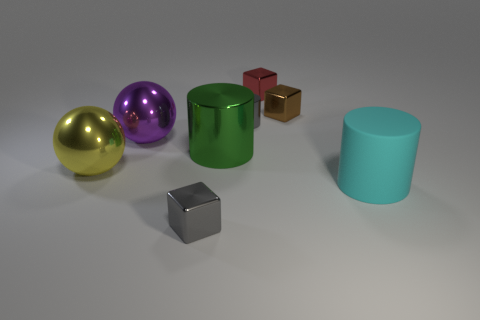There is a big thing that is to the left of the large purple metallic sphere to the left of the big green metal object; what is its material?
Provide a short and direct response. Metal. The cylinder that is the same size as the gray metal cube is what color?
Offer a terse response. Gray. There is a brown metallic thing; is its shape the same as the object that is behind the brown object?
Your answer should be compact. Yes. The thing that is the same color as the tiny cylinder is what shape?
Keep it short and to the point. Cube. There is a gray thing that is left of the cylinder that is behind the purple shiny thing; what number of big green cylinders are in front of it?
Provide a succinct answer. 0. How big is the gray metal object on the right side of the tiny cube in front of the large purple shiny thing?
Offer a very short reply. Small. The yellow object that is the same material as the brown thing is what size?
Your answer should be compact. Large. There is a big object that is on the right side of the purple metallic object and behind the big cyan matte cylinder; what shape is it?
Give a very brief answer. Cylinder. Are there the same number of matte things left of the green object and shiny blocks?
Keep it short and to the point. No. How many objects are gray shiny blocks or small metal things that are on the right side of the large green metallic object?
Provide a short and direct response. 4. 